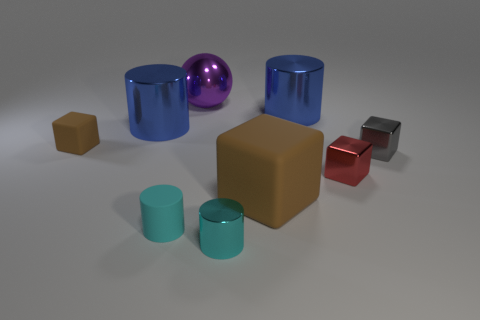Subtract all gray cubes. How many cubes are left? 3 Subtract all yellow cylinders. Subtract all red blocks. How many cylinders are left? 4 Subtract all spheres. How many objects are left? 8 Subtract 0 cyan blocks. How many objects are left? 9 Subtract all large purple shiny balls. Subtract all small cyan balls. How many objects are left? 8 Add 5 tiny red shiny blocks. How many tiny red shiny blocks are left? 6 Add 6 tiny red things. How many tiny red things exist? 7 